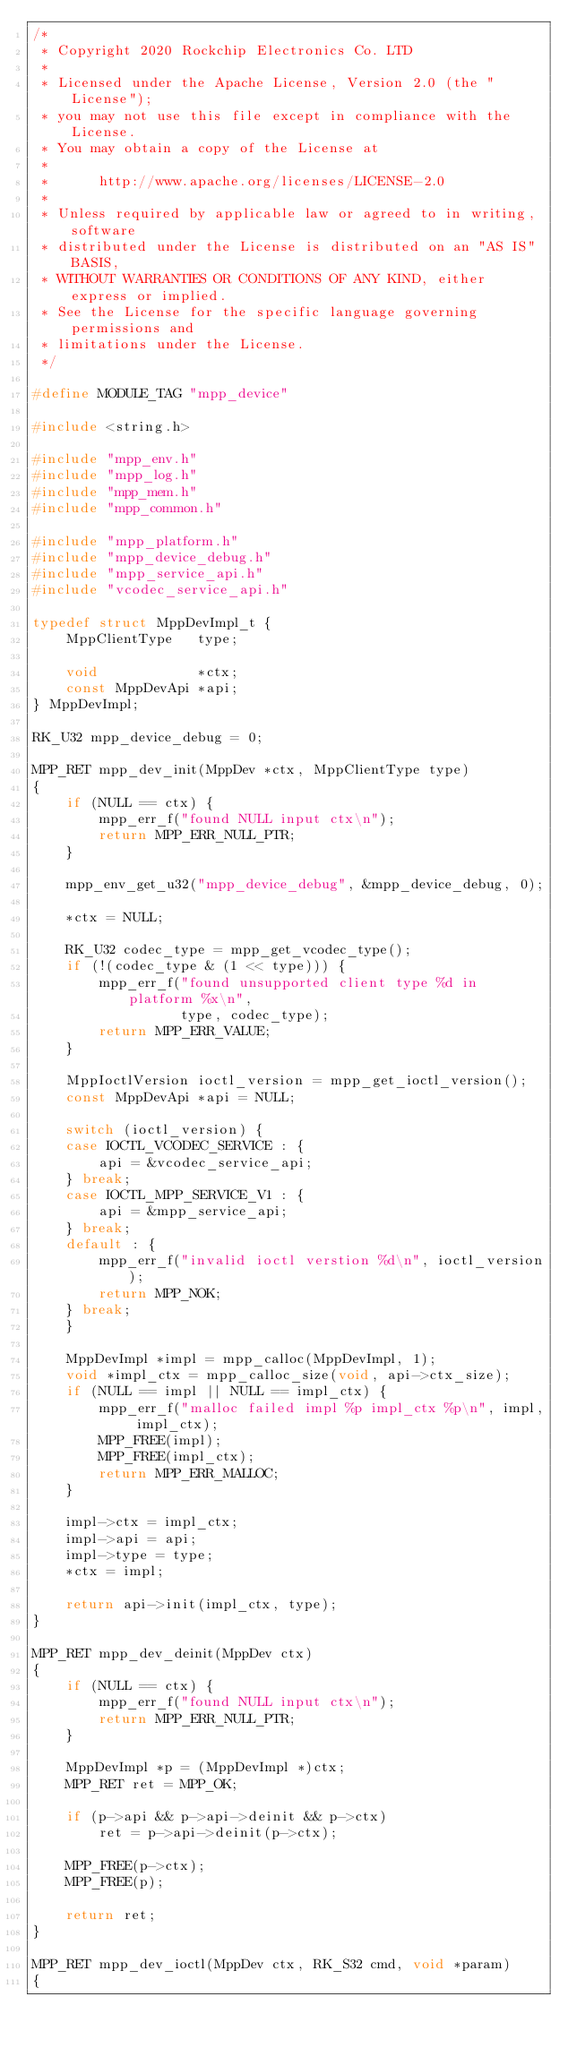<code> <loc_0><loc_0><loc_500><loc_500><_C_>/*
 * Copyright 2020 Rockchip Electronics Co. LTD
 *
 * Licensed under the Apache License, Version 2.0 (the "License");
 * you may not use this file except in compliance with the License.
 * You may obtain a copy of the License at
 *
 *      http://www.apache.org/licenses/LICENSE-2.0
 *
 * Unless required by applicable law or agreed to in writing, software
 * distributed under the License is distributed on an "AS IS" BASIS,
 * WITHOUT WARRANTIES OR CONDITIONS OF ANY KIND, either express or implied.
 * See the License for the specific language governing permissions and
 * limitations under the License.
 */

#define MODULE_TAG "mpp_device"

#include <string.h>

#include "mpp_env.h"
#include "mpp_log.h"
#include "mpp_mem.h"
#include "mpp_common.h"

#include "mpp_platform.h"
#include "mpp_device_debug.h"
#include "mpp_service_api.h"
#include "vcodec_service_api.h"

typedef struct MppDevImpl_t {
    MppClientType   type;

    void            *ctx;
    const MppDevApi *api;
} MppDevImpl;

RK_U32 mpp_device_debug = 0;

MPP_RET mpp_dev_init(MppDev *ctx, MppClientType type)
{
    if (NULL == ctx) {
        mpp_err_f("found NULL input ctx\n");
        return MPP_ERR_NULL_PTR;
    }

    mpp_env_get_u32("mpp_device_debug", &mpp_device_debug, 0);

    *ctx = NULL;

    RK_U32 codec_type = mpp_get_vcodec_type();
    if (!(codec_type & (1 << type))) {
        mpp_err_f("found unsupported client type %d in platform %x\n",
                  type, codec_type);
        return MPP_ERR_VALUE;
    }

    MppIoctlVersion ioctl_version = mpp_get_ioctl_version();
    const MppDevApi *api = NULL;

    switch (ioctl_version) {
    case IOCTL_VCODEC_SERVICE : {
        api = &vcodec_service_api;
    } break;
    case IOCTL_MPP_SERVICE_V1 : {
        api = &mpp_service_api;
    } break;
    default : {
        mpp_err_f("invalid ioctl verstion %d\n", ioctl_version);
        return MPP_NOK;
    } break;
    }

    MppDevImpl *impl = mpp_calloc(MppDevImpl, 1);
    void *impl_ctx = mpp_calloc_size(void, api->ctx_size);
    if (NULL == impl || NULL == impl_ctx) {
        mpp_err_f("malloc failed impl %p impl_ctx %p\n", impl, impl_ctx);
        MPP_FREE(impl);
        MPP_FREE(impl_ctx);
        return MPP_ERR_MALLOC;
    }

    impl->ctx = impl_ctx;
    impl->api = api;
    impl->type = type;
    *ctx = impl;

    return api->init(impl_ctx, type);
}

MPP_RET mpp_dev_deinit(MppDev ctx)
{
    if (NULL == ctx) {
        mpp_err_f("found NULL input ctx\n");
        return MPP_ERR_NULL_PTR;
    }

    MppDevImpl *p = (MppDevImpl *)ctx;
    MPP_RET ret = MPP_OK;

    if (p->api && p->api->deinit && p->ctx)
        ret = p->api->deinit(p->ctx);

    MPP_FREE(p->ctx);
    MPP_FREE(p);

    return ret;
}

MPP_RET mpp_dev_ioctl(MppDev ctx, RK_S32 cmd, void *param)
{</code> 